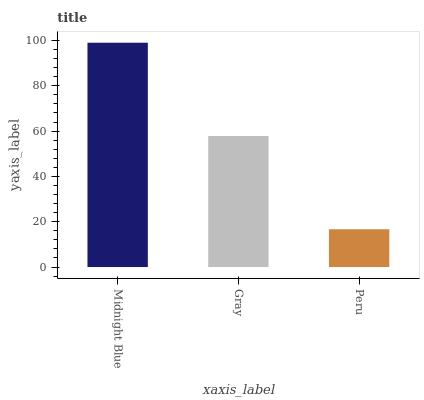Is Peru the minimum?
Answer yes or no. Yes. Is Midnight Blue the maximum?
Answer yes or no. Yes. Is Gray the minimum?
Answer yes or no. No. Is Gray the maximum?
Answer yes or no. No. Is Midnight Blue greater than Gray?
Answer yes or no. Yes. Is Gray less than Midnight Blue?
Answer yes or no. Yes. Is Gray greater than Midnight Blue?
Answer yes or no. No. Is Midnight Blue less than Gray?
Answer yes or no. No. Is Gray the high median?
Answer yes or no. Yes. Is Gray the low median?
Answer yes or no. Yes. Is Peru the high median?
Answer yes or no. No. Is Peru the low median?
Answer yes or no. No. 